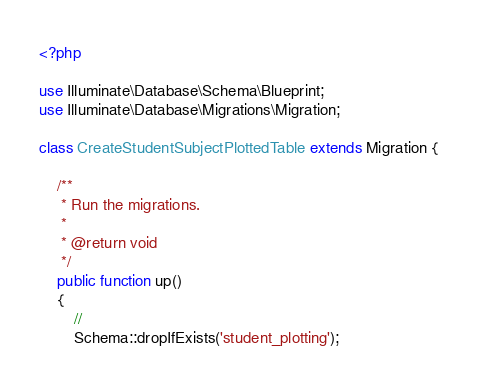<code> <loc_0><loc_0><loc_500><loc_500><_PHP_><?php

use Illuminate\Database\Schema\Blueprint;
use Illuminate\Database\Migrations\Migration;

class CreateStudentSubjectPlottedTable extends Migration {

	/**
	 * Run the migrations.
	 *
	 * @return void
	 */
	public function up()
	{
		//
		Schema::dropIfExists('student_plotting');</code> 